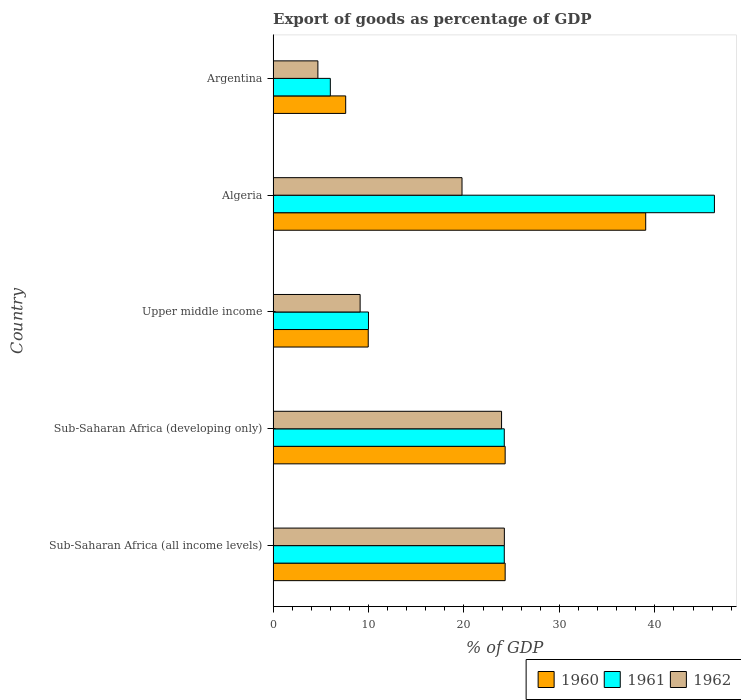Are the number of bars per tick equal to the number of legend labels?
Ensure brevity in your answer.  Yes. How many bars are there on the 2nd tick from the top?
Ensure brevity in your answer.  3. What is the label of the 4th group of bars from the top?
Offer a terse response. Sub-Saharan Africa (developing only). In how many cases, is the number of bars for a given country not equal to the number of legend labels?
Give a very brief answer. 0. What is the export of goods as percentage of GDP in 1962 in Sub-Saharan Africa (developing only)?
Provide a short and direct response. 23.94. Across all countries, what is the maximum export of goods as percentage of GDP in 1961?
Offer a terse response. 46.24. Across all countries, what is the minimum export of goods as percentage of GDP in 1961?
Ensure brevity in your answer.  5.99. In which country was the export of goods as percentage of GDP in 1960 maximum?
Provide a short and direct response. Algeria. What is the total export of goods as percentage of GDP in 1962 in the graph?
Offer a terse response. 81.77. What is the difference between the export of goods as percentage of GDP in 1962 in Algeria and that in Sub-Saharan Africa (developing only)?
Provide a short and direct response. -4.14. What is the difference between the export of goods as percentage of GDP in 1960 in Upper middle income and the export of goods as percentage of GDP in 1962 in Sub-Saharan Africa (developing only)?
Provide a short and direct response. -13.97. What is the average export of goods as percentage of GDP in 1961 per country?
Give a very brief answer. 22.14. What is the difference between the export of goods as percentage of GDP in 1962 and export of goods as percentage of GDP in 1960 in Algeria?
Your answer should be very brief. -19.25. In how many countries, is the export of goods as percentage of GDP in 1961 greater than 38 %?
Give a very brief answer. 1. What is the ratio of the export of goods as percentage of GDP in 1962 in Algeria to that in Argentina?
Ensure brevity in your answer.  4.22. Is the export of goods as percentage of GDP in 1961 in Algeria less than that in Sub-Saharan Africa (all income levels)?
Your response must be concise. No. Is the difference between the export of goods as percentage of GDP in 1962 in Algeria and Sub-Saharan Africa (developing only) greater than the difference between the export of goods as percentage of GDP in 1960 in Algeria and Sub-Saharan Africa (developing only)?
Your response must be concise. No. What is the difference between the highest and the second highest export of goods as percentage of GDP in 1962?
Your answer should be compact. 0.29. What is the difference between the highest and the lowest export of goods as percentage of GDP in 1962?
Offer a very short reply. 19.54. Is the sum of the export of goods as percentage of GDP in 1961 in Argentina and Sub-Saharan Africa (all income levels) greater than the maximum export of goods as percentage of GDP in 1960 across all countries?
Provide a short and direct response. No. What does the 1st bar from the top in Sub-Saharan Africa (all income levels) represents?
Offer a very short reply. 1962. Does the graph contain any zero values?
Offer a very short reply. No. Where does the legend appear in the graph?
Your response must be concise. Bottom right. How many legend labels are there?
Keep it short and to the point. 3. How are the legend labels stacked?
Ensure brevity in your answer.  Horizontal. What is the title of the graph?
Make the answer very short. Export of goods as percentage of GDP. What is the label or title of the X-axis?
Ensure brevity in your answer.  % of GDP. What is the % of GDP of 1960 in Sub-Saharan Africa (all income levels)?
Your response must be concise. 24.31. What is the % of GDP in 1961 in Sub-Saharan Africa (all income levels)?
Provide a short and direct response. 24.22. What is the % of GDP of 1962 in Sub-Saharan Africa (all income levels)?
Your answer should be compact. 24.23. What is the % of GDP in 1960 in Sub-Saharan Africa (developing only)?
Offer a terse response. 24.31. What is the % of GDP in 1961 in Sub-Saharan Africa (developing only)?
Provide a succinct answer. 24.22. What is the % of GDP in 1962 in Sub-Saharan Africa (developing only)?
Your response must be concise. 23.94. What is the % of GDP of 1960 in Upper middle income?
Keep it short and to the point. 9.97. What is the % of GDP of 1961 in Upper middle income?
Give a very brief answer. 9.99. What is the % of GDP in 1962 in Upper middle income?
Offer a very short reply. 9.12. What is the % of GDP of 1960 in Algeria?
Your answer should be compact. 39.04. What is the % of GDP in 1961 in Algeria?
Keep it short and to the point. 46.24. What is the % of GDP in 1962 in Algeria?
Offer a very short reply. 19.79. What is the % of GDP in 1960 in Argentina?
Your answer should be compact. 7.6. What is the % of GDP in 1961 in Argentina?
Your answer should be very brief. 5.99. What is the % of GDP in 1962 in Argentina?
Keep it short and to the point. 4.69. Across all countries, what is the maximum % of GDP of 1960?
Provide a short and direct response. 39.04. Across all countries, what is the maximum % of GDP of 1961?
Your answer should be very brief. 46.24. Across all countries, what is the maximum % of GDP in 1962?
Keep it short and to the point. 24.23. Across all countries, what is the minimum % of GDP of 1960?
Give a very brief answer. 7.6. Across all countries, what is the minimum % of GDP in 1961?
Offer a very short reply. 5.99. Across all countries, what is the minimum % of GDP in 1962?
Provide a succinct answer. 4.69. What is the total % of GDP of 1960 in the graph?
Your answer should be very brief. 105.24. What is the total % of GDP of 1961 in the graph?
Make the answer very short. 110.68. What is the total % of GDP of 1962 in the graph?
Provide a short and direct response. 81.77. What is the difference between the % of GDP of 1961 in Sub-Saharan Africa (all income levels) and that in Sub-Saharan Africa (developing only)?
Your answer should be compact. 0. What is the difference between the % of GDP of 1962 in Sub-Saharan Africa (all income levels) and that in Sub-Saharan Africa (developing only)?
Your answer should be compact. 0.29. What is the difference between the % of GDP of 1960 in Sub-Saharan Africa (all income levels) and that in Upper middle income?
Offer a terse response. 14.35. What is the difference between the % of GDP of 1961 in Sub-Saharan Africa (all income levels) and that in Upper middle income?
Provide a succinct answer. 14.23. What is the difference between the % of GDP in 1962 in Sub-Saharan Africa (all income levels) and that in Upper middle income?
Your response must be concise. 15.11. What is the difference between the % of GDP in 1960 in Sub-Saharan Africa (all income levels) and that in Algeria?
Your answer should be very brief. -14.73. What is the difference between the % of GDP in 1961 in Sub-Saharan Africa (all income levels) and that in Algeria?
Keep it short and to the point. -22.02. What is the difference between the % of GDP in 1962 in Sub-Saharan Africa (all income levels) and that in Algeria?
Provide a succinct answer. 4.44. What is the difference between the % of GDP in 1960 in Sub-Saharan Africa (all income levels) and that in Argentina?
Your answer should be very brief. 16.71. What is the difference between the % of GDP in 1961 in Sub-Saharan Africa (all income levels) and that in Argentina?
Your answer should be very brief. 18.23. What is the difference between the % of GDP in 1962 in Sub-Saharan Africa (all income levels) and that in Argentina?
Your answer should be compact. 19.54. What is the difference between the % of GDP of 1960 in Sub-Saharan Africa (developing only) and that in Upper middle income?
Ensure brevity in your answer.  14.35. What is the difference between the % of GDP in 1961 in Sub-Saharan Africa (developing only) and that in Upper middle income?
Keep it short and to the point. 14.23. What is the difference between the % of GDP in 1962 in Sub-Saharan Africa (developing only) and that in Upper middle income?
Offer a terse response. 14.82. What is the difference between the % of GDP of 1960 in Sub-Saharan Africa (developing only) and that in Algeria?
Provide a short and direct response. -14.73. What is the difference between the % of GDP in 1961 in Sub-Saharan Africa (developing only) and that in Algeria?
Offer a terse response. -22.02. What is the difference between the % of GDP in 1962 in Sub-Saharan Africa (developing only) and that in Algeria?
Keep it short and to the point. 4.14. What is the difference between the % of GDP in 1960 in Sub-Saharan Africa (developing only) and that in Argentina?
Provide a succinct answer. 16.71. What is the difference between the % of GDP in 1961 in Sub-Saharan Africa (developing only) and that in Argentina?
Your response must be concise. 18.23. What is the difference between the % of GDP in 1962 in Sub-Saharan Africa (developing only) and that in Argentina?
Your response must be concise. 19.25. What is the difference between the % of GDP of 1960 in Upper middle income and that in Algeria?
Offer a terse response. -29.08. What is the difference between the % of GDP in 1961 in Upper middle income and that in Algeria?
Make the answer very short. -36.25. What is the difference between the % of GDP in 1962 in Upper middle income and that in Algeria?
Offer a terse response. -10.68. What is the difference between the % of GDP in 1960 in Upper middle income and that in Argentina?
Offer a terse response. 2.36. What is the difference between the % of GDP of 1961 in Upper middle income and that in Argentina?
Make the answer very short. 4. What is the difference between the % of GDP in 1962 in Upper middle income and that in Argentina?
Your answer should be compact. 4.43. What is the difference between the % of GDP in 1960 in Algeria and that in Argentina?
Offer a terse response. 31.44. What is the difference between the % of GDP of 1961 in Algeria and that in Argentina?
Give a very brief answer. 40.25. What is the difference between the % of GDP of 1962 in Algeria and that in Argentina?
Provide a succinct answer. 15.1. What is the difference between the % of GDP of 1960 in Sub-Saharan Africa (all income levels) and the % of GDP of 1961 in Sub-Saharan Africa (developing only)?
Ensure brevity in your answer.  0.09. What is the difference between the % of GDP of 1960 in Sub-Saharan Africa (all income levels) and the % of GDP of 1962 in Sub-Saharan Africa (developing only)?
Keep it short and to the point. 0.38. What is the difference between the % of GDP of 1961 in Sub-Saharan Africa (all income levels) and the % of GDP of 1962 in Sub-Saharan Africa (developing only)?
Offer a very short reply. 0.28. What is the difference between the % of GDP in 1960 in Sub-Saharan Africa (all income levels) and the % of GDP in 1961 in Upper middle income?
Offer a terse response. 14.32. What is the difference between the % of GDP in 1960 in Sub-Saharan Africa (all income levels) and the % of GDP in 1962 in Upper middle income?
Your response must be concise. 15.2. What is the difference between the % of GDP in 1961 in Sub-Saharan Africa (all income levels) and the % of GDP in 1962 in Upper middle income?
Make the answer very short. 15.11. What is the difference between the % of GDP in 1960 in Sub-Saharan Africa (all income levels) and the % of GDP in 1961 in Algeria?
Your answer should be very brief. -21.93. What is the difference between the % of GDP in 1960 in Sub-Saharan Africa (all income levels) and the % of GDP in 1962 in Algeria?
Make the answer very short. 4.52. What is the difference between the % of GDP of 1961 in Sub-Saharan Africa (all income levels) and the % of GDP of 1962 in Algeria?
Make the answer very short. 4.43. What is the difference between the % of GDP in 1960 in Sub-Saharan Africa (all income levels) and the % of GDP in 1961 in Argentina?
Your response must be concise. 18.32. What is the difference between the % of GDP of 1960 in Sub-Saharan Africa (all income levels) and the % of GDP of 1962 in Argentina?
Offer a terse response. 19.62. What is the difference between the % of GDP in 1961 in Sub-Saharan Africa (all income levels) and the % of GDP in 1962 in Argentina?
Provide a succinct answer. 19.53. What is the difference between the % of GDP in 1960 in Sub-Saharan Africa (developing only) and the % of GDP in 1961 in Upper middle income?
Make the answer very short. 14.32. What is the difference between the % of GDP in 1960 in Sub-Saharan Africa (developing only) and the % of GDP in 1962 in Upper middle income?
Ensure brevity in your answer.  15.2. What is the difference between the % of GDP in 1961 in Sub-Saharan Africa (developing only) and the % of GDP in 1962 in Upper middle income?
Provide a succinct answer. 15.11. What is the difference between the % of GDP of 1960 in Sub-Saharan Africa (developing only) and the % of GDP of 1961 in Algeria?
Provide a succinct answer. -21.93. What is the difference between the % of GDP of 1960 in Sub-Saharan Africa (developing only) and the % of GDP of 1962 in Algeria?
Provide a short and direct response. 4.52. What is the difference between the % of GDP of 1961 in Sub-Saharan Africa (developing only) and the % of GDP of 1962 in Algeria?
Provide a succinct answer. 4.43. What is the difference between the % of GDP of 1960 in Sub-Saharan Africa (developing only) and the % of GDP of 1961 in Argentina?
Provide a succinct answer. 18.32. What is the difference between the % of GDP in 1960 in Sub-Saharan Africa (developing only) and the % of GDP in 1962 in Argentina?
Ensure brevity in your answer.  19.62. What is the difference between the % of GDP in 1961 in Sub-Saharan Africa (developing only) and the % of GDP in 1962 in Argentina?
Give a very brief answer. 19.53. What is the difference between the % of GDP in 1960 in Upper middle income and the % of GDP in 1961 in Algeria?
Provide a short and direct response. -36.28. What is the difference between the % of GDP in 1960 in Upper middle income and the % of GDP in 1962 in Algeria?
Give a very brief answer. -9.83. What is the difference between the % of GDP in 1961 in Upper middle income and the % of GDP in 1962 in Algeria?
Offer a terse response. -9.8. What is the difference between the % of GDP of 1960 in Upper middle income and the % of GDP of 1961 in Argentina?
Your answer should be very brief. 3.97. What is the difference between the % of GDP of 1960 in Upper middle income and the % of GDP of 1962 in Argentina?
Keep it short and to the point. 5.28. What is the difference between the % of GDP of 1961 in Upper middle income and the % of GDP of 1962 in Argentina?
Your answer should be very brief. 5.3. What is the difference between the % of GDP in 1960 in Algeria and the % of GDP in 1961 in Argentina?
Provide a short and direct response. 33.05. What is the difference between the % of GDP in 1960 in Algeria and the % of GDP in 1962 in Argentina?
Your answer should be very brief. 34.35. What is the difference between the % of GDP in 1961 in Algeria and the % of GDP in 1962 in Argentina?
Your answer should be very brief. 41.55. What is the average % of GDP of 1960 per country?
Provide a succinct answer. 21.05. What is the average % of GDP in 1961 per country?
Your answer should be compact. 22.14. What is the average % of GDP of 1962 per country?
Make the answer very short. 16.35. What is the difference between the % of GDP of 1960 and % of GDP of 1961 in Sub-Saharan Africa (all income levels)?
Your answer should be compact. 0.09. What is the difference between the % of GDP of 1960 and % of GDP of 1962 in Sub-Saharan Africa (all income levels)?
Offer a terse response. 0.08. What is the difference between the % of GDP of 1961 and % of GDP of 1962 in Sub-Saharan Africa (all income levels)?
Give a very brief answer. -0.01. What is the difference between the % of GDP of 1960 and % of GDP of 1961 in Sub-Saharan Africa (developing only)?
Your answer should be compact. 0.09. What is the difference between the % of GDP of 1960 and % of GDP of 1962 in Sub-Saharan Africa (developing only)?
Your response must be concise. 0.38. What is the difference between the % of GDP of 1961 and % of GDP of 1962 in Sub-Saharan Africa (developing only)?
Make the answer very short. 0.28. What is the difference between the % of GDP of 1960 and % of GDP of 1961 in Upper middle income?
Your response must be concise. -0.02. What is the difference between the % of GDP in 1960 and % of GDP in 1962 in Upper middle income?
Give a very brief answer. 0.85. What is the difference between the % of GDP of 1961 and % of GDP of 1962 in Upper middle income?
Offer a very short reply. 0.87. What is the difference between the % of GDP of 1960 and % of GDP of 1961 in Algeria?
Your answer should be very brief. -7.2. What is the difference between the % of GDP in 1960 and % of GDP in 1962 in Algeria?
Ensure brevity in your answer.  19.25. What is the difference between the % of GDP in 1961 and % of GDP in 1962 in Algeria?
Keep it short and to the point. 26.45. What is the difference between the % of GDP in 1960 and % of GDP in 1961 in Argentina?
Offer a very short reply. 1.61. What is the difference between the % of GDP in 1960 and % of GDP in 1962 in Argentina?
Offer a very short reply. 2.91. What is the difference between the % of GDP in 1961 and % of GDP in 1962 in Argentina?
Your answer should be compact. 1.3. What is the ratio of the % of GDP in 1960 in Sub-Saharan Africa (all income levels) to that in Sub-Saharan Africa (developing only)?
Keep it short and to the point. 1. What is the ratio of the % of GDP of 1961 in Sub-Saharan Africa (all income levels) to that in Sub-Saharan Africa (developing only)?
Ensure brevity in your answer.  1. What is the ratio of the % of GDP of 1962 in Sub-Saharan Africa (all income levels) to that in Sub-Saharan Africa (developing only)?
Provide a succinct answer. 1.01. What is the ratio of the % of GDP of 1960 in Sub-Saharan Africa (all income levels) to that in Upper middle income?
Provide a short and direct response. 2.44. What is the ratio of the % of GDP of 1961 in Sub-Saharan Africa (all income levels) to that in Upper middle income?
Provide a short and direct response. 2.42. What is the ratio of the % of GDP in 1962 in Sub-Saharan Africa (all income levels) to that in Upper middle income?
Give a very brief answer. 2.66. What is the ratio of the % of GDP in 1960 in Sub-Saharan Africa (all income levels) to that in Algeria?
Offer a very short reply. 0.62. What is the ratio of the % of GDP of 1961 in Sub-Saharan Africa (all income levels) to that in Algeria?
Keep it short and to the point. 0.52. What is the ratio of the % of GDP of 1962 in Sub-Saharan Africa (all income levels) to that in Algeria?
Your answer should be compact. 1.22. What is the ratio of the % of GDP of 1960 in Sub-Saharan Africa (all income levels) to that in Argentina?
Ensure brevity in your answer.  3.2. What is the ratio of the % of GDP of 1961 in Sub-Saharan Africa (all income levels) to that in Argentina?
Keep it short and to the point. 4.04. What is the ratio of the % of GDP of 1962 in Sub-Saharan Africa (all income levels) to that in Argentina?
Offer a very short reply. 5.16. What is the ratio of the % of GDP of 1960 in Sub-Saharan Africa (developing only) to that in Upper middle income?
Your answer should be compact. 2.44. What is the ratio of the % of GDP in 1961 in Sub-Saharan Africa (developing only) to that in Upper middle income?
Offer a terse response. 2.42. What is the ratio of the % of GDP in 1962 in Sub-Saharan Africa (developing only) to that in Upper middle income?
Offer a terse response. 2.63. What is the ratio of the % of GDP in 1960 in Sub-Saharan Africa (developing only) to that in Algeria?
Your response must be concise. 0.62. What is the ratio of the % of GDP of 1961 in Sub-Saharan Africa (developing only) to that in Algeria?
Offer a very short reply. 0.52. What is the ratio of the % of GDP in 1962 in Sub-Saharan Africa (developing only) to that in Algeria?
Ensure brevity in your answer.  1.21. What is the ratio of the % of GDP in 1960 in Sub-Saharan Africa (developing only) to that in Argentina?
Ensure brevity in your answer.  3.2. What is the ratio of the % of GDP of 1961 in Sub-Saharan Africa (developing only) to that in Argentina?
Offer a terse response. 4.04. What is the ratio of the % of GDP in 1962 in Sub-Saharan Africa (developing only) to that in Argentina?
Keep it short and to the point. 5.1. What is the ratio of the % of GDP in 1960 in Upper middle income to that in Algeria?
Provide a short and direct response. 0.26. What is the ratio of the % of GDP in 1961 in Upper middle income to that in Algeria?
Ensure brevity in your answer.  0.22. What is the ratio of the % of GDP in 1962 in Upper middle income to that in Algeria?
Make the answer very short. 0.46. What is the ratio of the % of GDP in 1960 in Upper middle income to that in Argentina?
Give a very brief answer. 1.31. What is the ratio of the % of GDP of 1961 in Upper middle income to that in Argentina?
Ensure brevity in your answer.  1.67. What is the ratio of the % of GDP in 1962 in Upper middle income to that in Argentina?
Ensure brevity in your answer.  1.94. What is the ratio of the % of GDP in 1960 in Algeria to that in Argentina?
Make the answer very short. 5.13. What is the ratio of the % of GDP of 1961 in Algeria to that in Argentina?
Make the answer very short. 7.71. What is the ratio of the % of GDP in 1962 in Algeria to that in Argentina?
Ensure brevity in your answer.  4.22. What is the difference between the highest and the second highest % of GDP in 1960?
Your response must be concise. 14.73. What is the difference between the highest and the second highest % of GDP of 1961?
Give a very brief answer. 22.02. What is the difference between the highest and the second highest % of GDP in 1962?
Provide a short and direct response. 0.29. What is the difference between the highest and the lowest % of GDP of 1960?
Make the answer very short. 31.44. What is the difference between the highest and the lowest % of GDP of 1961?
Your response must be concise. 40.25. What is the difference between the highest and the lowest % of GDP of 1962?
Ensure brevity in your answer.  19.54. 